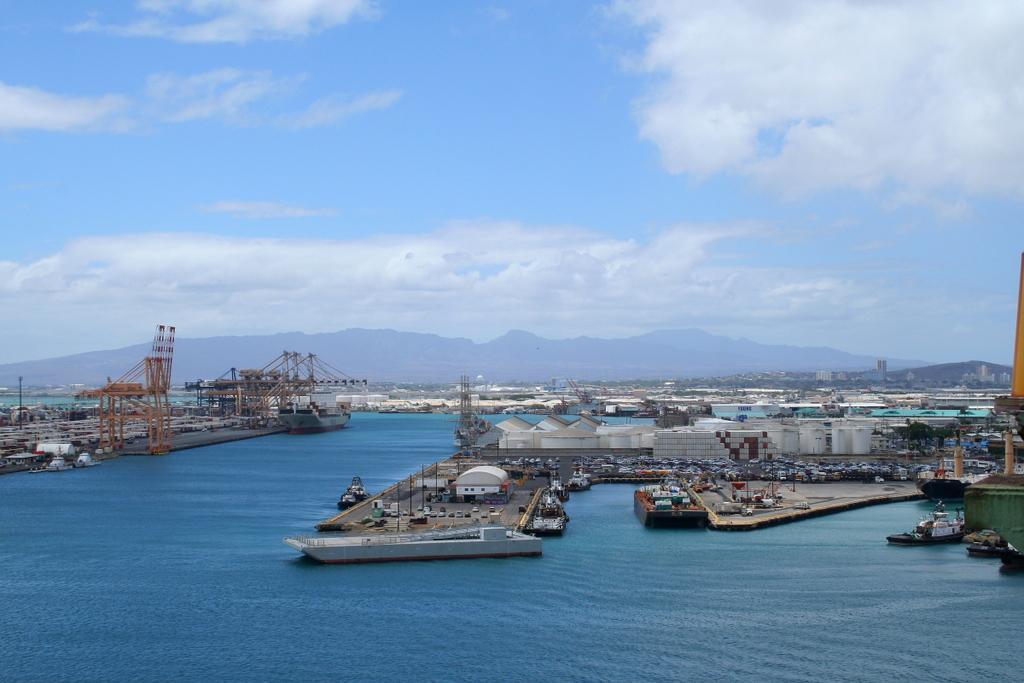Describe this image in one or two sentences. In this image we can see water, vehicles, boats, ships, towers, poles, pillars, and buildings. In the background we can see mountain and sky with clouds. 